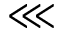Convert formula to latex. <formula><loc_0><loc_0><loc_500><loc_500>\lll</formula> 